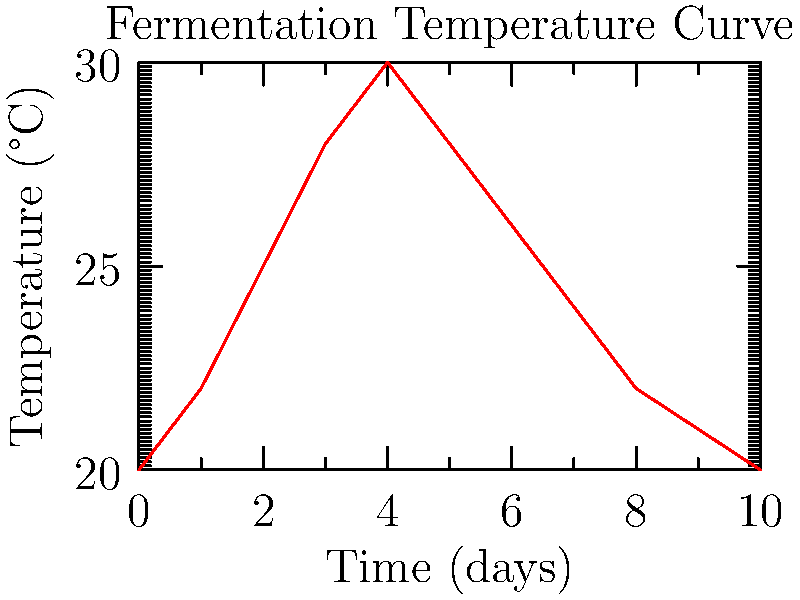Based on the temperature curve shown for wine fermentation, at approximately which day does the fermentation process reach its peak temperature? To determine the day when fermentation reaches its peak temperature, we need to analyze the curve:

1. The x-axis represents time in days, while the y-axis shows temperature in °C.
2. The curve starts at 20°C on day 0 and gradually rises.
3. It reaches its highest point around the middle of the graph.
4. After careful observation, we can see that the curve peaks at 30°C.
5. This peak occurs at day 4 on the x-axis.
6. After day 4, the temperature begins to decrease, indicating the end of the most active fermentation phase.

The peak of fermentation, characterized by the highest temperature, occurs on day 4. This is typical in wine fermentation, where the most vigorous activity happens in the first few days before gradually slowing down.
Answer: Day 4 